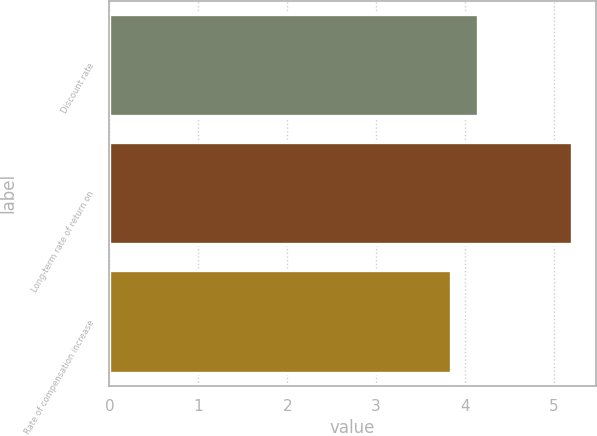Convert chart. <chart><loc_0><loc_0><loc_500><loc_500><bar_chart><fcel>Discount rate<fcel>Long-term rate of return on<fcel>Rate of compensation increase<nl><fcel>4.15<fcel>5.21<fcel>3.84<nl></chart> 